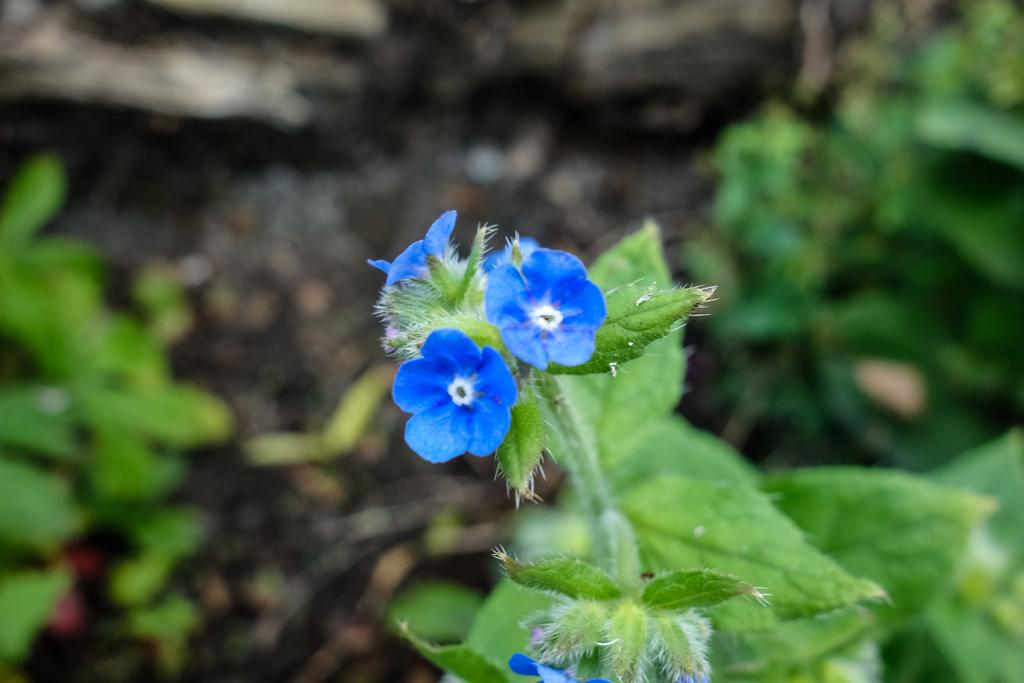What type of living organisms can be seen in the image? There are flowers and plants visible in the image. Can you describe the background of the image? The background of the image is blurry. What type of spark can be seen coming from the scarecrow in the image? There is no scarecrow present in the image, and therefore no spark can be observed. 